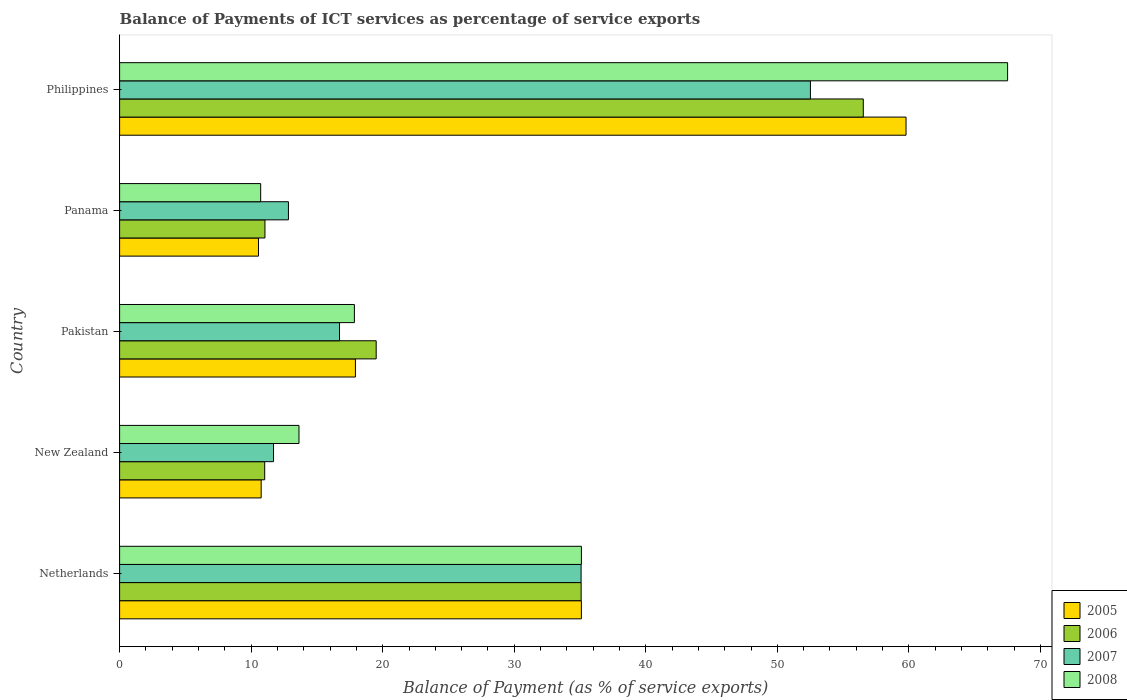How many groups of bars are there?
Your response must be concise. 5. Are the number of bars per tick equal to the number of legend labels?
Keep it short and to the point. Yes. Are the number of bars on each tick of the Y-axis equal?
Make the answer very short. Yes. How many bars are there on the 2nd tick from the top?
Offer a terse response. 4. How many bars are there on the 5th tick from the bottom?
Your response must be concise. 4. What is the label of the 4th group of bars from the top?
Provide a succinct answer. New Zealand. What is the balance of payments of ICT services in 2005 in Philippines?
Your answer should be very brief. 59.78. Across all countries, what is the maximum balance of payments of ICT services in 2008?
Offer a very short reply. 67.5. Across all countries, what is the minimum balance of payments of ICT services in 2008?
Your answer should be compact. 10.72. In which country was the balance of payments of ICT services in 2006 maximum?
Provide a short and direct response. Philippines. In which country was the balance of payments of ICT services in 2007 minimum?
Keep it short and to the point. New Zealand. What is the total balance of payments of ICT services in 2005 in the graph?
Give a very brief answer. 134.13. What is the difference between the balance of payments of ICT services in 2005 in Netherlands and that in Philippines?
Provide a succinct answer. -24.68. What is the difference between the balance of payments of ICT services in 2007 in Netherlands and the balance of payments of ICT services in 2008 in New Zealand?
Offer a very short reply. 21.44. What is the average balance of payments of ICT services in 2005 per country?
Your answer should be compact. 26.83. What is the difference between the balance of payments of ICT services in 2006 and balance of payments of ICT services in 2007 in Panama?
Ensure brevity in your answer.  -1.78. What is the ratio of the balance of payments of ICT services in 2007 in Netherlands to that in Panama?
Keep it short and to the point. 2.73. Is the difference between the balance of payments of ICT services in 2006 in Netherlands and Panama greater than the difference between the balance of payments of ICT services in 2007 in Netherlands and Panama?
Provide a short and direct response. Yes. What is the difference between the highest and the second highest balance of payments of ICT services in 2007?
Provide a short and direct response. 17.43. What is the difference between the highest and the lowest balance of payments of ICT services in 2006?
Ensure brevity in your answer.  45.5. In how many countries, is the balance of payments of ICT services in 2008 greater than the average balance of payments of ICT services in 2008 taken over all countries?
Ensure brevity in your answer.  2. Is the sum of the balance of payments of ICT services in 2007 in New Zealand and Panama greater than the maximum balance of payments of ICT services in 2005 across all countries?
Offer a very short reply. No. What does the 2nd bar from the bottom in Panama represents?
Provide a succinct answer. 2006. How many bars are there?
Your response must be concise. 20. Are all the bars in the graph horizontal?
Give a very brief answer. Yes. How many countries are there in the graph?
Your response must be concise. 5. Are the values on the major ticks of X-axis written in scientific E-notation?
Provide a short and direct response. No. Does the graph contain grids?
Your answer should be compact. No. Where does the legend appear in the graph?
Provide a succinct answer. Bottom right. How many legend labels are there?
Offer a very short reply. 4. How are the legend labels stacked?
Ensure brevity in your answer.  Vertical. What is the title of the graph?
Ensure brevity in your answer.  Balance of Payments of ICT services as percentage of service exports. What is the label or title of the X-axis?
Ensure brevity in your answer.  Balance of Payment (as % of service exports). What is the label or title of the Y-axis?
Give a very brief answer. Country. What is the Balance of Payment (as % of service exports) in 2005 in Netherlands?
Your answer should be compact. 35.1. What is the Balance of Payment (as % of service exports) of 2006 in Netherlands?
Ensure brevity in your answer.  35.09. What is the Balance of Payment (as % of service exports) in 2007 in Netherlands?
Give a very brief answer. 35.08. What is the Balance of Payment (as % of service exports) in 2008 in Netherlands?
Give a very brief answer. 35.11. What is the Balance of Payment (as % of service exports) in 2005 in New Zealand?
Provide a succinct answer. 10.76. What is the Balance of Payment (as % of service exports) in 2006 in New Zealand?
Offer a very short reply. 11.03. What is the Balance of Payment (as % of service exports) in 2007 in New Zealand?
Keep it short and to the point. 11.7. What is the Balance of Payment (as % of service exports) of 2008 in New Zealand?
Provide a succinct answer. 13.64. What is the Balance of Payment (as % of service exports) in 2005 in Pakistan?
Offer a very short reply. 17.93. What is the Balance of Payment (as % of service exports) in 2006 in Pakistan?
Offer a terse response. 19.51. What is the Balance of Payment (as % of service exports) in 2007 in Pakistan?
Your response must be concise. 16.72. What is the Balance of Payment (as % of service exports) in 2008 in Pakistan?
Offer a terse response. 17.85. What is the Balance of Payment (as % of service exports) of 2005 in Panama?
Keep it short and to the point. 10.56. What is the Balance of Payment (as % of service exports) of 2006 in Panama?
Provide a succinct answer. 11.05. What is the Balance of Payment (as % of service exports) of 2007 in Panama?
Make the answer very short. 12.83. What is the Balance of Payment (as % of service exports) of 2008 in Panama?
Make the answer very short. 10.72. What is the Balance of Payment (as % of service exports) in 2005 in Philippines?
Your answer should be compact. 59.78. What is the Balance of Payment (as % of service exports) in 2006 in Philippines?
Give a very brief answer. 56.53. What is the Balance of Payment (as % of service exports) in 2007 in Philippines?
Make the answer very short. 52.51. What is the Balance of Payment (as % of service exports) in 2008 in Philippines?
Ensure brevity in your answer.  67.5. Across all countries, what is the maximum Balance of Payment (as % of service exports) of 2005?
Your response must be concise. 59.78. Across all countries, what is the maximum Balance of Payment (as % of service exports) of 2006?
Your response must be concise. 56.53. Across all countries, what is the maximum Balance of Payment (as % of service exports) of 2007?
Provide a short and direct response. 52.51. Across all countries, what is the maximum Balance of Payment (as % of service exports) in 2008?
Keep it short and to the point. 67.5. Across all countries, what is the minimum Balance of Payment (as % of service exports) in 2005?
Keep it short and to the point. 10.56. Across all countries, what is the minimum Balance of Payment (as % of service exports) in 2006?
Provide a succinct answer. 11.03. Across all countries, what is the minimum Balance of Payment (as % of service exports) in 2007?
Give a very brief answer. 11.7. Across all countries, what is the minimum Balance of Payment (as % of service exports) of 2008?
Ensure brevity in your answer.  10.72. What is the total Balance of Payment (as % of service exports) of 2005 in the graph?
Give a very brief answer. 134.13. What is the total Balance of Payment (as % of service exports) in 2006 in the graph?
Provide a succinct answer. 133.21. What is the total Balance of Payment (as % of service exports) of 2007 in the graph?
Offer a very short reply. 128.85. What is the total Balance of Payment (as % of service exports) of 2008 in the graph?
Offer a very short reply. 144.82. What is the difference between the Balance of Payment (as % of service exports) in 2005 in Netherlands and that in New Zealand?
Keep it short and to the point. 24.34. What is the difference between the Balance of Payment (as % of service exports) of 2006 in Netherlands and that in New Zealand?
Provide a succinct answer. 24.05. What is the difference between the Balance of Payment (as % of service exports) of 2007 in Netherlands and that in New Zealand?
Your answer should be very brief. 23.38. What is the difference between the Balance of Payment (as % of service exports) of 2008 in Netherlands and that in New Zealand?
Keep it short and to the point. 21.47. What is the difference between the Balance of Payment (as % of service exports) of 2005 in Netherlands and that in Pakistan?
Your answer should be compact. 17.18. What is the difference between the Balance of Payment (as % of service exports) of 2006 in Netherlands and that in Pakistan?
Offer a terse response. 15.58. What is the difference between the Balance of Payment (as % of service exports) of 2007 in Netherlands and that in Pakistan?
Ensure brevity in your answer.  18.36. What is the difference between the Balance of Payment (as % of service exports) in 2008 in Netherlands and that in Pakistan?
Offer a terse response. 17.26. What is the difference between the Balance of Payment (as % of service exports) of 2005 in Netherlands and that in Panama?
Your answer should be compact. 24.55. What is the difference between the Balance of Payment (as % of service exports) of 2006 in Netherlands and that in Panama?
Offer a terse response. 24.04. What is the difference between the Balance of Payment (as % of service exports) in 2007 in Netherlands and that in Panama?
Make the answer very short. 22.25. What is the difference between the Balance of Payment (as % of service exports) in 2008 in Netherlands and that in Panama?
Your answer should be compact. 24.38. What is the difference between the Balance of Payment (as % of service exports) of 2005 in Netherlands and that in Philippines?
Ensure brevity in your answer.  -24.68. What is the difference between the Balance of Payment (as % of service exports) of 2006 in Netherlands and that in Philippines?
Offer a very short reply. -21.45. What is the difference between the Balance of Payment (as % of service exports) of 2007 in Netherlands and that in Philippines?
Keep it short and to the point. -17.43. What is the difference between the Balance of Payment (as % of service exports) of 2008 in Netherlands and that in Philippines?
Provide a short and direct response. -32.4. What is the difference between the Balance of Payment (as % of service exports) of 2005 in New Zealand and that in Pakistan?
Provide a short and direct response. -7.16. What is the difference between the Balance of Payment (as % of service exports) of 2006 in New Zealand and that in Pakistan?
Offer a terse response. -8.47. What is the difference between the Balance of Payment (as % of service exports) in 2007 in New Zealand and that in Pakistan?
Provide a short and direct response. -5.02. What is the difference between the Balance of Payment (as % of service exports) in 2008 in New Zealand and that in Pakistan?
Provide a succinct answer. -4.21. What is the difference between the Balance of Payment (as % of service exports) in 2005 in New Zealand and that in Panama?
Your answer should be compact. 0.2. What is the difference between the Balance of Payment (as % of service exports) in 2006 in New Zealand and that in Panama?
Keep it short and to the point. -0.02. What is the difference between the Balance of Payment (as % of service exports) of 2007 in New Zealand and that in Panama?
Your answer should be very brief. -1.13. What is the difference between the Balance of Payment (as % of service exports) of 2008 in New Zealand and that in Panama?
Provide a short and direct response. 2.91. What is the difference between the Balance of Payment (as % of service exports) in 2005 in New Zealand and that in Philippines?
Your answer should be very brief. -49.02. What is the difference between the Balance of Payment (as % of service exports) of 2006 in New Zealand and that in Philippines?
Offer a terse response. -45.5. What is the difference between the Balance of Payment (as % of service exports) in 2007 in New Zealand and that in Philippines?
Offer a terse response. -40.81. What is the difference between the Balance of Payment (as % of service exports) of 2008 in New Zealand and that in Philippines?
Your response must be concise. -53.87. What is the difference between the Balance of Payment (as % of service exports) in 2005 in Pakistan and that in Panama?
Offer a terse response. 7.37. What is the difference between the Balance of Payment (as % of service exports) in 2006 in Pakistan and that in Panama?
Your answer should be compact. 8.46. What is the difference between the Balance of Payment (as % of service exports) of 2007 in Pakistan and that in Panama?
Your answer should be compact. 3.88. What is the difference between the Balance of Payment (as % of service exports) in 2008 in Pakistan and that in Panama?
Give a very brief answer. 7.12. What is the difference between the Balance of Payment (as % of service exports) of 2005 in Pakistan and that in Philippines?
Provide a succinct answer. -41.86. What is the difference between the Balance of Payment (as % of service exports) of 2006 in Pakistan and that in Philippines?
Provide a short and direct response. -37.03. What is the difference between the Balance of Payment (as % of service exports) of 2007 in Pakistan and that in Philippines?
Keep it short and to the point. -35.8. What is the difference between the Balance of Payment (as % of service exports) in 2008 in Pakistan and that in Philippines?
Offer a terse response. -49.66. What is the difference between the Balance of Payment (as % of service exports) in 2005 in Panama and that in Philippines?
Offer a terse response. -49.23. What is the difference between the Balance of Payment (as % of service exports) of 2006 in Panama and that in Philippines?
Provide a short and direct response. -45.48. What is the difference between the Balance of Payment (as % of service exports) in 2007 in Panama and that in Philippines?
Provide a succinct answer. -39.68. What is the difference between the Balance of Payment (as % of service exports) in 2008 in Panama and that in Philippines?
Provide a short and direct response. -56.78. What is the difference between the Balance of Payment (as % of service exports) of 2005 in Netherlands and the Balance of Payment (as % of service exports) of 2006 in New Zealand?
Provide a succinct answer. 24.07. What is the difference between the Balance of Payment (as % of service exports) in 2005 in Netherlands and the Balance of Payment (as % of service exports) in 2007 in New Zealand?
Make the answer very short. 23.4. What is the difference between the Balance of Payment (as % of service exports) of 2005 in Netherlands and the Balance of Payment (as % of service exports) of 2008 in New Zealand?
Offer a terse response. 21.47. What is the difference between the Balance of Payment (as % of service exports) in 2006 in Netherlands and the Balance of Payment (as % of service exports) in 2007 in New Zealand?
Provide a short and direct response. 23.38. What is the difference between the Balance of Payment (as % of service exports) in 2006 in Netherlands and the Balance of Payment (as % of service exports) in 2008 in New Zealand?
Keep it short and to the point. 21.45. What is the difference between the Balance of Payment (as % of service exports) of 2007 in Netherlands and the Balance of Payment (as % of service exports) of 2008 in New Zealand?
Provide a short and direct response. 21.44. What is the difference between the Balance of Payment (as % of service exports) of 2005 in Netherlands and the Balance of Payment (as % of service exports) of 2006 in Pakistan?
Keep it short and to the point. 15.6. What is the difference between the Balance of Payment (as % of service exports) of 2005 in Netherlands and the Balance of Payment (as % of service exports) of 2007 in Pakistan?
Offer a terse response. 18.39. What is the difference between the Balance of Payment (as % of service exports) of 2005 in Netherlands and the Balance of Payment (as % of service exports) of 2008 in Pakistan?
Your answer should be compact. 17.25. What is the difference between the Balance of Payment (as % of service exports) in 2006 in Netherlands and the Balance of Payment (as % of service exports) in 2007 in Pakistan?
Keep it short and to the point. 18.37. What is the difference between the Balance of Payment (as % of service exports) in 2006 in Netherlands and the Balance of Payment (as % of service exports) in 2008 in Pakistan?
Ensure brevity in your answer.  17.24. What is the difference between the Balance of Payment (as % of service exports) of 2007 in Netherlands and the Balance of Payment (as % of service exports) of 2008 in Pakistan?
Offer a terse response. 17.23. What is the difference between the Balance of Payment (as % of service exports) of 2005 in Netherlands and the Balance of Payment (as % of service exports) of 2006 in Panama?
Your response must be concise. 24.05. What is the difference between the Balance of Payment (as % of service exports) of 2005 in Netherlands and the Balance of Payment (as % of service exports) of 2007 in Panama?
Provide a short and direct response. 22.27. What is the difference between the Balance of Payment (as % of service exports) in 2005 in Netherlands and the Balance of Payment (as % of service exports) in 2008 in Panama?
Give a very brief answer. 24.38. What is the difference between the Balance of Payment (as % of service exports) in 2006 in Netherlands and the Balance of Payment (as % of service exports) in 2007 in Panama?
Your answer should be very brief. 22.25. What is the difference between the Balance of Payment (as % of service exports) in 2006 in Netherlands and the Balance of Payment (as % of service exports) in 2008 in Panama?
Provide a short and direct response. 24.36. What is the difference between the Balance of Payment (as % of service exports) in 2007 in Netherlands and the Balance of Payment (as % of service exports) in 2008 in Panama?
Provide a succinct answer. 24.36. What is the difference between the Balance of Payment (as % of service exports) in 2005 in Netherlands and the Balance of Payment (as % of service exports) in 2006 in Philippines?
Offer a very short reply. -21.43. What is the difference between the Balance of Payment (as % of service exports) of 2005 in Netherlands and the Balance of Payment (as % of service exports) of 2007 in Philippines?
Offer a very short reply. -17.41. What is the difference between the Balance of Payment (as % of service exports) in 2005 in Netherlands and the Balance of Payment (as % of service exports) in 2008 in Philippines?
Your response must be concise. -32.4. What is the difference between the Balance of Payment (as % of service exports) in 2006 in Netherlands and the Balance of Payment (as % of service exports) in 2007 in Philippines?
Keep it short and to the point. -17.43. What is the difference between the Balance of Payment (as % of service exports) in 2006 in Netherlands and the Balance of Payment (as % of service exports) in 2008 in Philippines?
Your answer should be compact. -32.42. What is the difference between the Balance of Payment (as % of service exports) of 2007 in Netherlands and the Balance of Payment (as % of service exports) of 2008 in Philippines?
Your answer should be very brief. -32.42. What is the difference between the Balance of Payment (as % of service exports) in 2005 in New Zealand and the Balance of Payment (as % of service exports) in 2006 in Pakistan?
Your answer should be compact. -8.74. What is the difference between the Balance of Payment (as % of service exports) of 2005 in New Zealand and the Balance of Payment (as % of service exports) of 2007 in Pakistan?
Provide a short and direct response. -5.96. What is the difference between the Balance of Payment (as % of service exports) of 2005 in New Zealand and the Balance of Payment (as % of service exports) of 2008 in Pakistan?
Offer a very short reply. -7.09. What is the difference between the Balance of Payment (as % of service exports) in 2006 in New Zealand and the Balance of Payment (as % of service exports) in 2007 in Pakistan?
Your answer should be very brief. -5.69. What is the difference between the Balance of Payment (as % of service exports) of 2006 in New Zealand and the Balance of Payment (as % of service exports) of 2008 in Pakistan?
Ensure brevity in your answer.  -6.82. What is the difference between the Balance of Payment (as % of service exports) in 2007 in New Zealand and the Balance of Payment (as % of service exports) in 2008 in Pakistan?
Offer a terse response. -6.15. What is the difference between the Balance of Payment (as % of service exports) of 2005 in New Zealand and the Balance of Payment (as % of service exports) of 2006 in Panama?
Ensure brevity in your answer.  -0.29. What is the difference between the Balance of Payment (as % of service exports) of 2005 in New Zealand and the Balance of Payment (as % of service exports) of 2007 in Panama?
Keep it short and to the point. -2.07. What is the difference between the Balance of Payment (as % of service exports) in 2005 in New Zealand and the Balance of Payment (as % of service exports) in 2008 in Panama?
Keep it short and to the point. 0.04. What is the difference between the Balance of Payment (as % of service exports) in 2006 in New Zealand and the Balance of Payment (as % of service exports) in 2007 in Panama?
Your answer should be compact. -1.8. What is the difference between the Balance of Payment (as % of service exports) in 2006 in New Zealand and the Balance of Payment (as % of service exports) in 2008 in Panama?
Keep it short and to the point. 0.31. What is the difference between the Balance of Payment (as % of service exports) in 2007 in New Zealand and the Balance of Payment (as % of service exports) in 2008 in Panama?
Give a very brief answer. 0.98. What is the difference between the Balance of Payment (as % of service exports) of 2005 in New Zealand and the Balance of Payment (as % of service exports) of 2006 in Philippines?
Your answer should be very brief. -45.77. What is the difference between the Balance of Payment (as % of service exports) in 2005 in New Zealand and the Balance of Payment (as % of service exports) in 2007 in Philippines?
Make the answer very short. -41.75. What is the difference between the Balance of Payment (as % of service exports) in 2005 in New Zealand and the Balance of Payment (as % of service exports) in 2008 in Philippines?
Make the answer very short. -56.74. What is the difference between the Balance of Payment (as % of service exports) in 2006 in New Zealand and the Balance of Payment (as % of service exports) in 2007 in Philippines?
Ensure brevity in your answer.  -41.48. What is the difference between the Balance of Payment (as % of service exports) in 2006 in New Zealand and the Balance of Payment (as % of service exports) in 2008 in Philippines?
Ensure brevity in your answer.  -56.47. What is the difference between the Balance of Payment (as % of service exports) in 2007 in New Zealand and the Balance of Payment (as % of service exports) in 2008 in Philippines?
Offer a terse response. -55.8. What is the difference between the Balance of Payment (as % of service exports) of 2005 in Pakistan and the Balance of Payment (as % of service exports) of 2006 in Panama?
Provide a succinct answer. 6.88. What is the difference between the Balance of Payment (as % of service exports) in 2005 in Pakistan and the Balance of Payment (as % of service exports) in 2007 in Panama?
Provide a short and direct response. 5.09. What is the difference between the Balance of Payment (as % of service exports) in 2005 in Pakistan and the Balance of Payment (as % of service exports) in 2008 in Panama?
Provide a short and direct response. 7.2. What is the difference between the Balance of Payment (as % of service exports) in 2006 in Pakistan and the Balance of Payment (as % of service exports) in 2007 in Panama?
Keep it short and to the point. 6.67. What is the difference between the Balance of Payment (as % of service exports) of 2006 in Pakistan and the Balance of Payment (as % of service exports) of 2008 in Panama?
Keep it short and to the point. 8.78. What is the difference between the Balance of Payment (as % of service exports) in 2007 in Pakistan and the Balance of Payment (as % of service exports) in 2008 in Panama?
Your answer should be very brief. 5.99. What is the difference between the Balance of Payment (as % of service exports) in 2005 in Pakistan and the Balance of Payment (as % of service exports) in 2006 in Philippines?
Make the answer very short. -38.61. What is the difference between the Balance of Payment (as % of service exports) in 2005 in Pakistan and the Balance of Payment (as % of service exports) in 2007 in Philippines?
Give a very brief answer. -34.59. What is the difference between the Balance of Payment (as % of service exports) of 2005 in Pakistan and the Balance of Payment (as % of service exports) of 2008 in Philippines?
Provide a short and direct response. -49.58. What is the difference between the Balance of Payment (as % of service exports) of 2006 in Pakistan and the Balance of Payment (as % of service exports) of 2007 in Philippines?
Your response must be concise. -33.01. What is the difference between the Balance of Payment (as % of service exports) in 2006 in Pakistan and the Balance of Payment (as % of service exports) in 2008 in Philippines?
Make the answer very short. -48. What is the difference between the Balance of Payment (as % of service exports) of 2007 in Pakistan and the Balance of Payment (as % of service exports) of 2008 in Philippines?
Provide a short and direct response. -50.79. What is the difference between the Balance of Payment (as % of service exports) of 2005 in Panama and the Balance of Payment (as % of service exports) of 2006 in Philippines?
Your response must be concise. -45.98. What is the difference between the Balance of Payment (as % of service exports) of 2005 in Panama and the Balance of Payment (as % of service exports) of 2007 in Philippines?
Offer a very short reply. -41.96. What is the difference between the Balance of Payment (as % of service exports) of 2005 in Panama and the Balance of Payment (as % of service exports) of 2008 in Philippines?
Your answer should be compact. -56.95. What is the difference between the Balance of Payment (as % of service exports) in 2006 in Panama and the Balance of Payment (as % of service exports) in 2007 in Philippines?
Offer a very short reply. -41.46. What is the difference between the Balance of Payment (as % of service exports) in 2006 in Panama and the Balance of Payment (as % of service exports) in 2008 in Philippines?
Keep it short and to the point. -56.45. What is the difference between the Balance of Payment (as % of service exports) of 2007 in Panama and the Balance of Payment (as % of service exports) of 2008 in Philippines?
Give a very brief answer. -54.67. What is the average Balance of Payment (as % of service exports) of 2005 per country?
Your response must be concise. 26.83. What is the average Balance of Payment (as % of service exports) of 2006 per country?
Your response must be concise. 26.64. What is the average Balance of Payment (as % of service exports) in 2007 per country?
Make the answer very short. 25.77. What is the average Balance of Payment (as % of service exports) of 2008 per country?
Your response must be concise. 28.96. What is the difference between the Balance of Payment (as % of service exports) of 2005 and Balance of Payment (as % of service exports) of 2006 in Netherlands?
Offer a very short reply. 0.02. What is the difference between the Balance of Payment (as % of service exports) in 2005 and Balance of Payment (as % of service exports) in 2007 in Netherlands?
Offer a terse response. 0.02. What is the difference between the Balance of Payment (as % of service exports) in 2005 and Balance of Payment (as % of service exports) in 2008 in Netherlands?
Your response must be concise. -0. What is the difference between the Balance of Payment (as % of service exports) in 2006 and Balance of Payment (as % of service exports) in 2007 in Netherlands?
Your response must be concise. 0. What is the difference between the Balance of Payment (as % of service exports) in 2006 and Balance of Payment (as % of service exports) in 2008 in Netherlands?
Offer a very short reply. -0.02. What is the difference between the Balance of Payment (as % of service exports) in 2007 and Balance of Payment (as % of service exports) in 2008 in Netherlands?
Your answer should be compact. -0.02. What is the difference between the Balance of Payment (as % of service exports) of 2005 and Balance of Payment (as % of service exports) of 2006 in New Zealand?
Offer a very short reply. -0.27. What is the difference between the Balance of Payment (as % of service exports) of 2005 and Balance of Payment (as % of service exports) of 2007 in New Zealand?
Give a very brief answer. -0.94. What is the difference between the Balance of Payment (as % of service exports) in 2005 and Balance of Payment (as % of service exports) in 2008 in New Zealand?
Make the answer very short. -2.87. What is the difference between the Balance of Payment (as % of service exports) in 2006 and Balance of Payment (as % of service exports) in 2007 in New Zealand?
Make the answer very short. -0.67. What is the difference between the Balance of Payment (as % of service exports) in 2006 and Balance of Payment (as % of service exports) in 2008 in New Zealand?
Provide a short and direct response. -2.61. What is the difference between the Balance of Payment (as % of service exports) of 2007 and Balance of Payment (as % of service exports) of 2008 in New Zealand?
Offer a very short reply. -1.94. What is the difference between the Balance of Payment (as % of service exports) of 2005 and Balance of Payment (as % of service exports) of 2006 in Pakistan?
Offer a very short reply. -1.58. What is the difference between the Balance of Payment (as % of service exports) in 2005 and Balance of Payment (as % of service exports) in 2007 in Pakistan?
Provide a short and direct response. 1.21. What is the difference between the Balance of Payment (as % of service exports) in 2005 and Balance of Payment (as % of service exports) in 2008 in Pakistan?
Provide a succinct answer. 0.08. What is the difference between the Balance of Payment (as % of service exports) of 2006 and Balance of Payment (as % of service exports) of 2007 in Pakistan?
Offer a terse response. 2.79. What is the difference between the Balance of Payment (as % of service exports) in 2006 and Balance of Payment (as % of service exports) in 2008 in Pakistan?
Make the answer very short. 1.66. What is the difference between the Balance of Payment (as % of service exports) in 2007 and Balance of Payment (as % of service exports) in 2008 in Pakistan?
Provide a short and direct response. -1.13. What is the difference between the Balance of Payment (as % of service exports) of 2005 and Balance of Payment (as % of service exports) of 2006 in Panama?
Keep it short and to the point. -0.49. What is the difference between the Balance of Payment (as % of service exports) in 2005 and Balance of Payment (as % of service exports) in 2007 in Panama?
Give a very brief answer. -2.28. What is the difference between the Balance of Payment (as % of service exports) of 2005 and Balance of Payment (as % of service exports) of 2008 in Panama?
Keep it short and to the point. -0.17. What is the difference between the Balance of Payment (as % of service exports) of 2006 and Balance of Payment (as % of service exports) of 2007 in Panama?
Give a very brief answer. -1.78. What is the difference between the Balance of Payment (as % of service exports) in 2006 and Balance of Payment (as % of service exports) in 2008 in Panama?
Make the answer very short. 0.33. What is the difference between the Balance of Payment (as % of service exports) in 2007 and Balance of Payment (as % of service exports) in 2008 in Panama?
Make the answer very short. 2.11. What is the difference between the Balance of Payment (as % of service exports) in 2005 and Balance of Payment (as % of service exports) in 2006 in Philippines?
Your response must be concise. 3.25. What is the difference between the Balance of Payment (as % of service exports) of 2005 and Balance of Payment (as % of service exports) of 2007 in Philippines?
Give a very brief answer. 7.27. What is the difference between the Balance of Payment (as % of service exports) in 2005 and Balance of Payment (as % of service exports) in 2008 in Philippines?
Offer a very short reply. -7.72. What is the difference between the Balance of Payment (as % of service exports) in 2006 and Balance of Payment (as % of service exports) in 2007 in Philippines?
Your answer should be very brief. 4.02. What is the difference between the Balance of Payment (as % of service exports) in 2006 and Balance of Payment (as % of service exports) in 2008 in Philippines?
Offer a terse response. -10.97. What is the difference between the Balance of Payment (as % of service exports) in 2007 and Balance of Payment (as % of service exports) in 2008 in Philippines?
Provide a short and direct response. -14.99. What is the ratio of the Balance of Payment (as % of service exports) in 2005 in Netherlands to that in New Zealand?
Offer a terse response. 3.26. What is the ratio of the Balance of Payment (as % of service exports) in 2006 in Netherlands to that in New Zealand?
Make the answer very short. 3.18. What is the ratio of the Balance of Payment (as % of service exports) of 2007 in Netherlands to that in New Zealand?
Offer a terse response. 3. What is the ratio of the Balance of Payment (as % of service exports) in 2008 in Netherlands to that in New Zealand?
Offer a terse response. 2.57. What is the ratio of the Balance of Payment (as % of service exports) in 2005 in Netherlands to that in Pakistan?
Ensure brevity in your answer.  1.96. What is the ratio of the Balance of Payment (as % of service exports) in 2006 in Netherlands to that in Pakistan?
Offer a terse response. 1.8. What is the ratio of the Balance of Payment (as % of service exports) of 2007 in Netherlands to that in Pakistan?
Make the answer very short. 2.1. What is the ratio of the Balance of Payment (as % of service exports) in 2008 in Netherlands to that in Pakistan?
Offer a terse response. 1.97. What is the ratio of the Balance of Payment (as % of service exports) in 2005 in Netherlands to that in Panama?
Offer a very short reply. 3.33. What is the ratio of the Balance of Payment (as % of service exports) in 2006 in Netherlands to that in Panama?
Make the answer very short. 3.18. What is the ratio of the Balance of Payment (as % of service exports) in 2007 in Netherlands to that in Panama?
Provide a succinct answer. 2.73. What is the ratio of the Balance of Payment (as % of service exports) of 2008 in Netherlands to that in Panama?
Provide a short and direct response. 3.27. What is the ratio of the Balance of Payment (as % of service exports) of 2005 in Netherlands to that in Philippines?
Ensure brevity in your answer.  0.59. What is the ratio of the Balance of Payment (as % of service exports) of 2006 in Netherlands to that in Philippines?
Give a very brief answer. 0.62. What is the ratio of the Balance of Payment (as % of service exports) of 2007 in Netherlands to that in Philippines?
Offer a very short reply. 0.67. What is the ratio of the Balance of Payment (as % of service exports) of 2008 in Netherlands to that in Philippines?
Give a very brief answer. 0.52. What is the ratio of the Balance of Payment (as % of service exports) in 2005 in New Zealand to that in Pakistan?
Provide a succinct answer. 0.6. What is the ratio of the Balance of Payment (as % of service exports) in 2006 in New Zealand to that in Pakistan?
Keep it short and to the point. 0.57. What is the ratio of the Balance of Payment (as % of service exports) of 2007 in New Zealand to that in Pakistan?
Your answer should be very brief. 0.7. What is the ratio of the Balance of Payment (as % of service exports) of 2008 in New Zealand to that in Pakistan?
Provide a succinct answer. 0.76. What is the ratio of the Balance of Payment (as % of service exports) in 2005 in New Zealand to that in Panama?
Offer a terse response. 1.02. What is the ratio of the Balance of Payment (as % of service exports) in 2006 in New Zealand to that in Panama?
Provide a succinct answer. 1. What is the ratio of the Balance of Payment (as % of service exports) of 2007 in New Zealand to that in Panama?
Provide a succinct answer. 0.91. What is the ratio of the Balance of Payment (as % of service exports) in 2008 in New Zealand to that in Panama?
Ensure brevity in your answer.  1.27. What is the ratio of the Balance of Payment (as % of service exports) in 2005 in New Zealand to that in Philippines?
Provide a short and direct response. 0.18. What is the ratio of the Balance of Payment (as % of service exports) of 2006 in New Zealand to that in Philippines?
Ensure brevity in your answer.  0.2. What is the ratio of the Balance of Payment (as % of service exports) in 2007 in New Zealand to that in Philippines?
Offer a terse response. 0.22. What is the ratio of the Balance of Payment (as % of service exports) in 2008 in New Zealand to that in Philippines?
Make the answer very short. 0.2. What is the ratio of the Balance of Payment (as % of service exports) in 2005 in Pakistan to that in Panama?
Your answer should be very brief. 1.7. What is the ratio of the Balance of Payment (as % of service exports) of 2006 in Pakistan to that in Panama?
Your answer should be compact. 1.77. What is the ratio of the Balance of Payment (as % of service exports) in 2007 in Pakistan to that in Panama?
Make the answer very short. 1.3. What is the ratio of the Balance of Payment (as % of service exports) of 2008 in Pakistan to that in Panama?
Make the answer very short. 1.66. What is the ratio of the Balance of Payment (as % of service exports) of 2005 in Pakistan to that in Philippines?
Your answer should be compact. 0.3. What is the ratio of the Balance of Payment (as % of service exports) of 2006 in Pakistan to that in Philippines?
Give a very brief answer. 0.34. What is the ratio of the Balance of Payment (as % of service exports) of 2007 in Pakistan to that in Philippines?
Give a very brief answer. 0.32. What is the ratio of the Balance of Payment (as % of service exports) of 2008 in Pakistan to that in Philippines?
Offer a terse response. 0.26. What is the ratio of the Balance of Payment (as % of service exports) of 2005 in Panama to that in Philippines?
Make the answer very short. 0.18. What is the ratio of the Balance of Payment (as % of service exports) of 2006 in Panama to that in Philippines?
Offer a very short reply. 0.2. What is the ratio of the Balance of Payment (as % of service exports) of 2007 in Panama to that in Philippines?
Ensure brevity in your answer.  0.24. What is the ratio of the Balance of Payment (as % of service exports) of 2008 in Panama to that in Philippines?
Ensure brevity in your answer.  0.16. What is the difference between the highest and the second highest Balance of Payment (as % of service exports) of 2005?
Offer a terse response. 24.68. What is the difference between the highest and the second highest Balance of Payment (as % of service exports) of 2006?
Your answer should be compact. 21.45. What is the difference between the highest and the second highest Balance of Payment (as % of service exports) in 2007?
Keep it short and to the point. 17.43. What is the difference between the highest and the second highest Balance of Payment (as % of service exports) of 2008?
Your answer should be compact. 32.4. What is the difference between the highest and the lowest Balance of Payment (as % of service exports) in 2005?
Keep it short and to the point. 49.23. What is the difference between the highest and the lowest Balance of Payment (as % of service exports) of 2006?
Provide a short and direct response. 45.5. What is the difference between the highest and the lowest Balance of Payment (as % of service exports) in 2007?
Provide a succinct answer. 40.81. What is the difference between the highest and the lowest Balance of Payment (as % of service exports) of 2008?
Give a very brief answer. 56.78. 